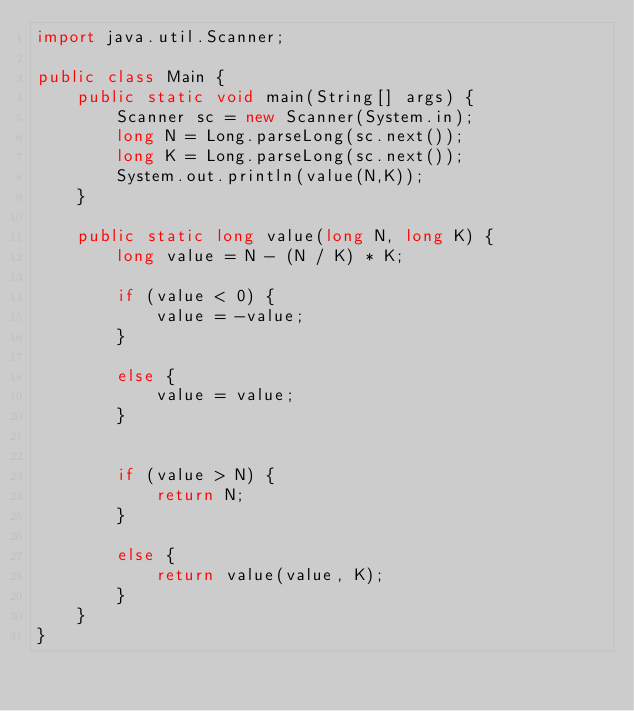<code> <loc_0><loc_0><loc_500><loc_500><_Java_>import java.util.Scanner;

public class Main {
    public static void main(String[] args) {
        Scanner sc = new Scanner(System.in);
        long N = Long.parseLong(sc.next());
        long K = Long.parseLong(sc.next());
        System.out.println(value(N,K));
    }

    public static long value(long N, long K) {
        long value = N - (N / K) * K;

        if (value < 0) {
            value = -value;
        }

        else {
            value = value;
        }


        if (value > N) {
            return N;
        }

        else {
            return value(value, K);
        }
    }
}


</code> 